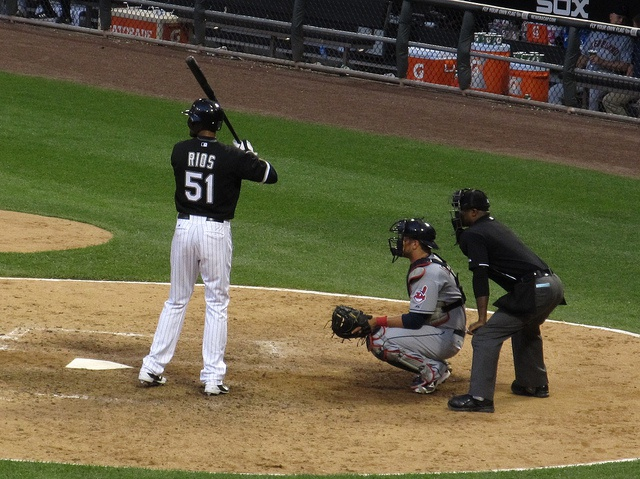Describe the objects in this image and their specific colors. I can see people in black, lavender, and darkgray tones, people in black, darkgreen, gray, and tan tones, people in black, gray, and maroon tones, people in black, gray, and darkblue tones, and baseball glove in black and gray tones in this image. 